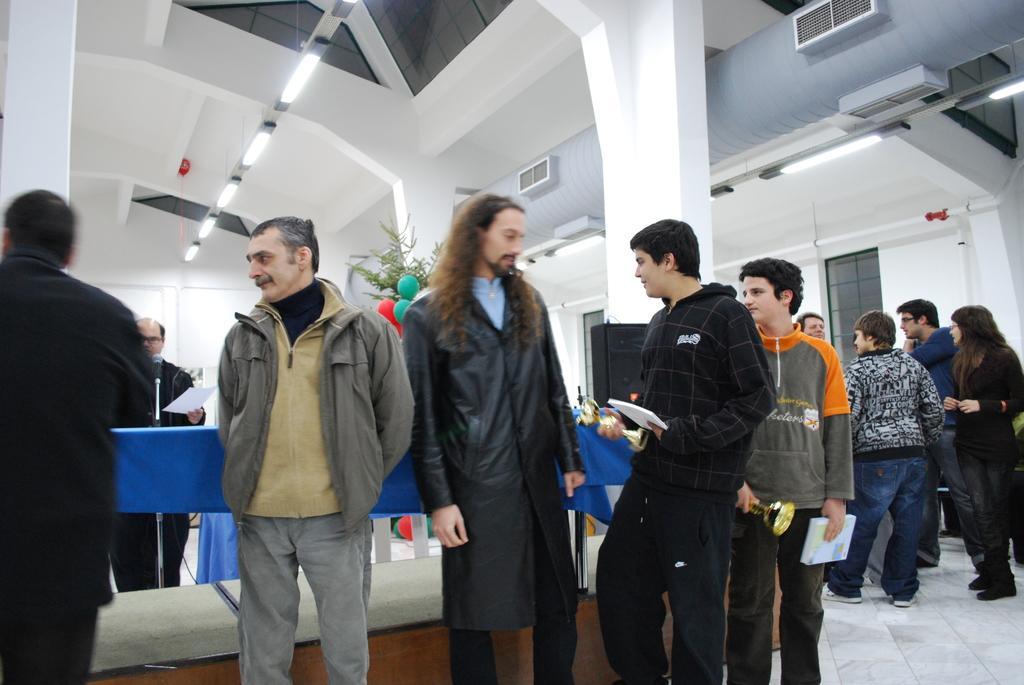In one or two sentences, can you explain what this image depicts? In this image there are people standing on the floor. There is a table with blue color cloth on it. On top of it there is a mike. There is a speaker. Behind the table there is a plant. There are balloons. In the background of the image there is a wall. On the right side of the image there are windows. On top of the image there are lights. 